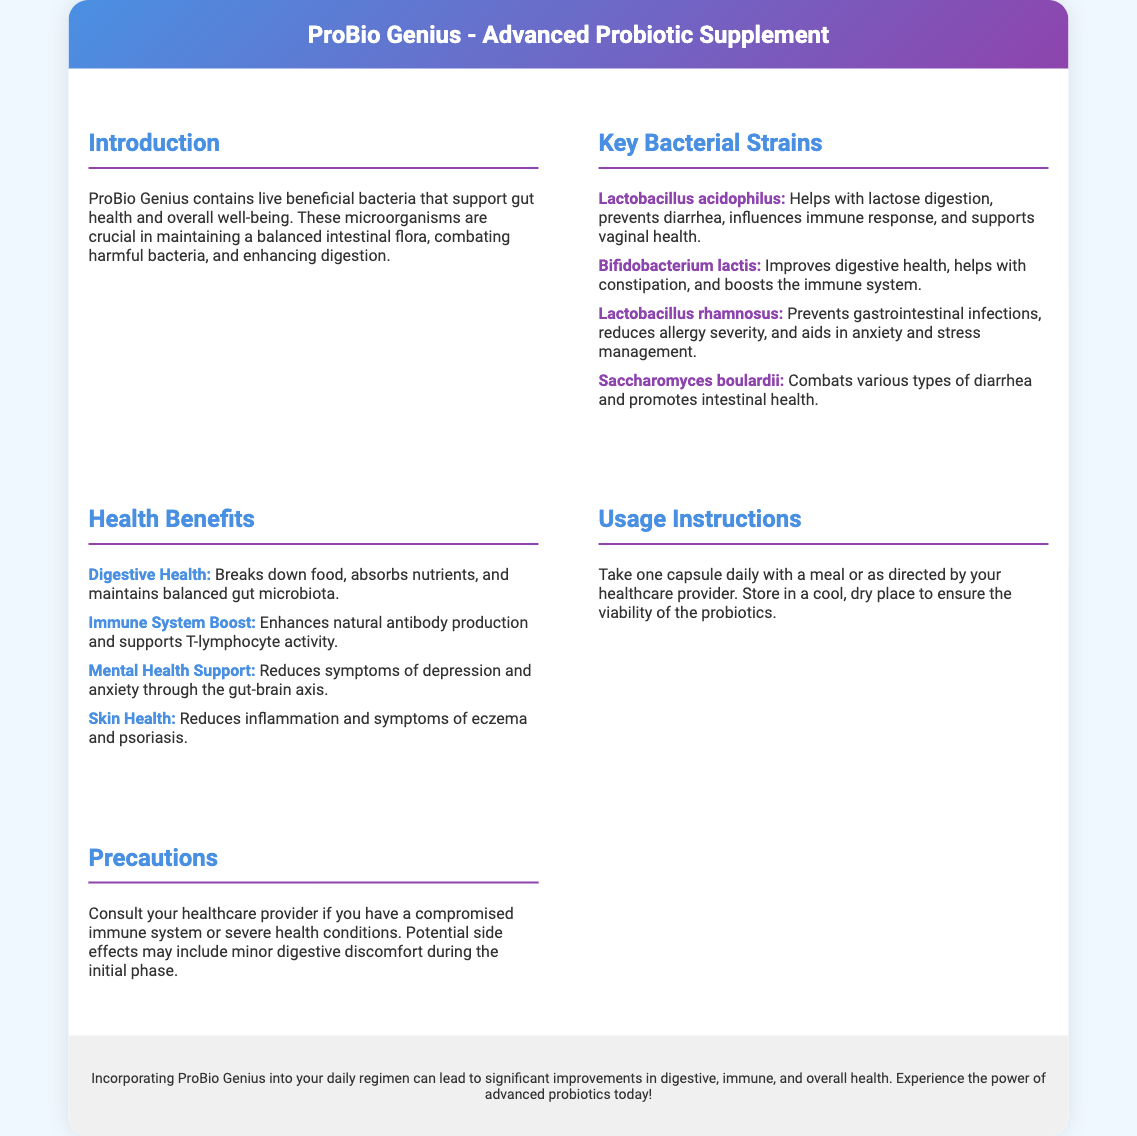What are probiotics? Probiotics are live beneficial bacteria that support gut health and overall well-being.
Answer: Live beneficial bacteria What strain helps with lactose digestion? The specific strain that helps with lactose digestion is mentioned in the document.
Answer: Lactobacillus acidophilus What is one benefit of Bifidobacterium lactis? The document lists multiple benefits for this strain; this one focuses on its specific role.
Answer: Improves digestive health How often should ProBio Genius be taken? The usage instructions in the document specify how frequently the supplement should be consumed.
Answer: One capsule daily What health benefit is related to the gut-brain axis? The health benefits section connects this benefit with mental health.
Answer: Mental Health Support What precaution should be taken for individuals with severe health conditions? The document suggests a specific action for this situation.
Answer: Consult your healthcare provider What is the main focus of the introduction? The introduction summarizes the role and importance of the product.
Answer: Gut health and overall well-being What type of health does Saccharomyces boulardii primarily support? This strain primarily addresses a specific health issue outlined in the document.
Answer: Intestinal health 